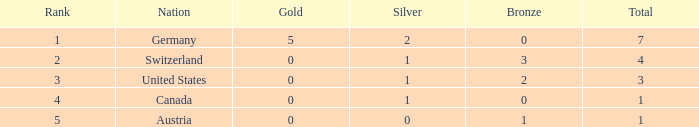What is the full amount of Total for Austria when the number of gold is less than 0? None. 